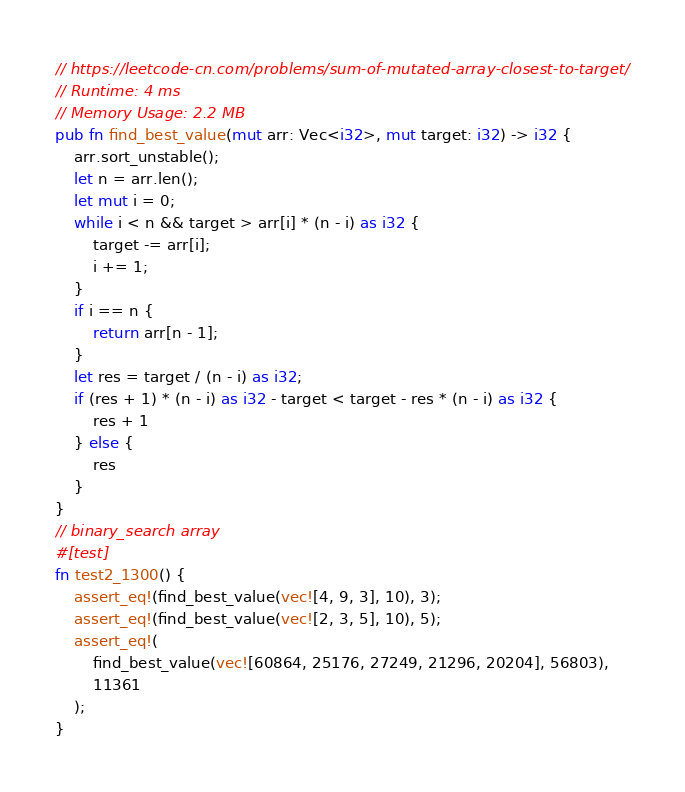Convert code to text. <code><loc_0><loc_0><loc_500><loc_500><_Rust_>// https://leetcode-cn.com/problems/sum-of-mutated-array-closest-to-target/
// Runtime: 4 ms
// Memory Usage: 2.2 MB
pub fn find_best_value(mut arr: Vec<i32>, mut target: i32) -> i32 {
    arr.sort_unstable();
    let n = arr.len();
    let mut i = 0;
    while i < n && target > arr[i] * (n - i) as i32 {
        target -= arr[i];
        i += 1;
    }
    if i == n {
        return arr[n - 1];
    }
    let res = target / (n - i) as i32;
    if (res + 1) * (n - i) as i32 - target < target - res * (n - i) as i32 {
        res + 1
    } else {
        res
    }
}
// binary_search array
#[test]
fn test2_1300() {
    assert_eq!(find_best_value(vec![4, 9, 3], 10), 3);
    assert_eq!(find_best_value(vec![2, 3, 5], 10), 5);
    assert_eq!(
        find_best_value(vec![60864, 25176, 27249, 21296, 20204], 56803),
        11361
    );
}
</code> 